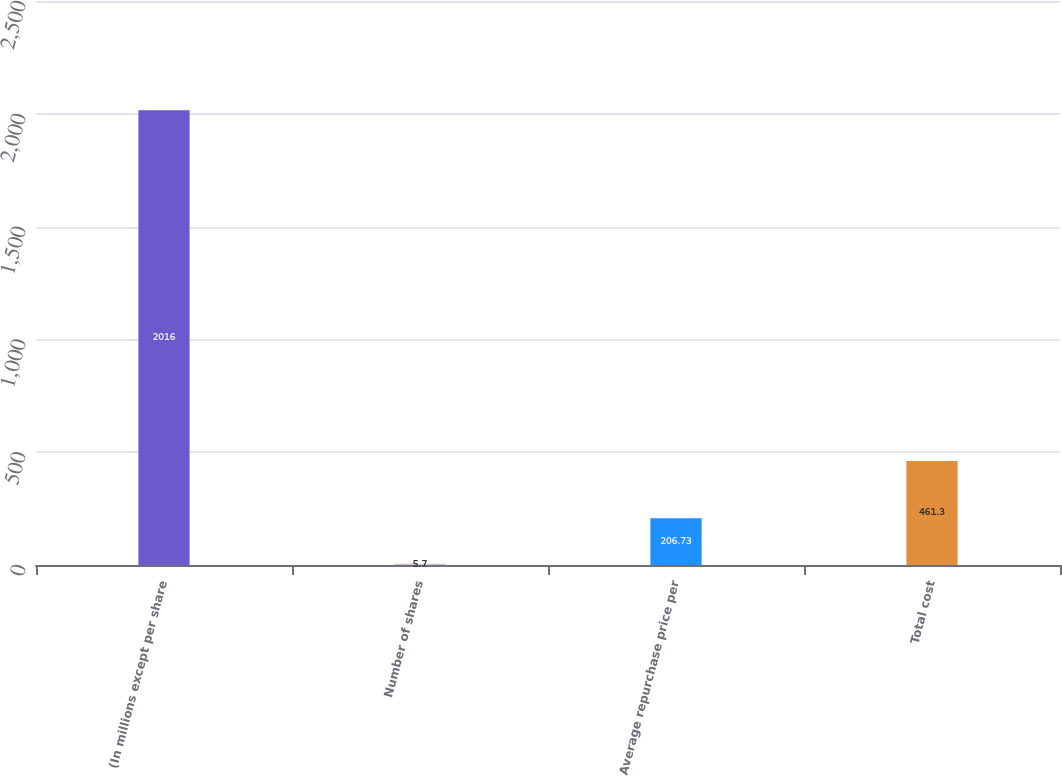Convert chart. <chart><loc_0><loc_0><loc_500><loc_500><bar_chart><fcel>(In millions except per share<fcel>Number of shares<fcel>Average repurchase price per<fcel>Total cost<nl><fcel>2016<fcel>5.7<fcel>206.73<fcel>461.3<nl></chart> 